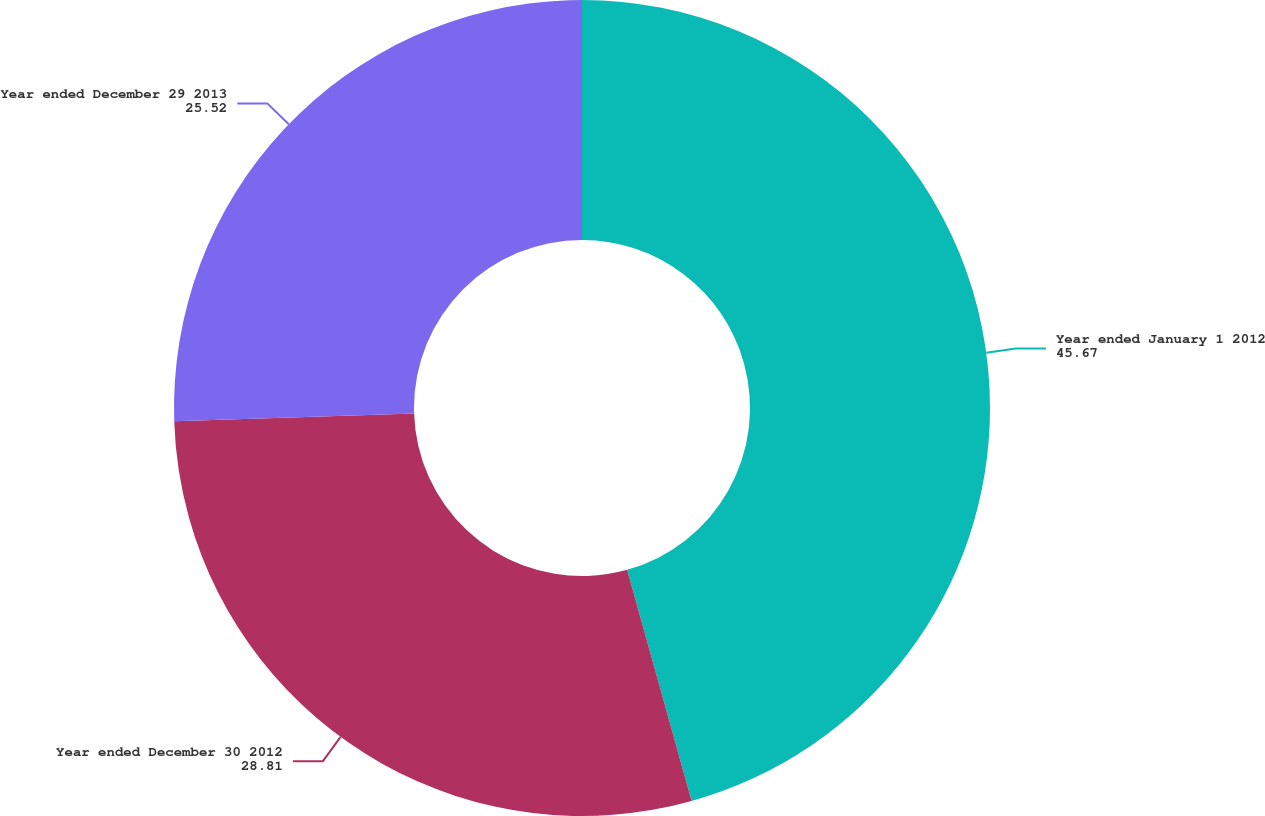<chart> <loc_0><loc_0><loc_500><loc_500><pie_chart><fcel>Year ended January 1 2012<fcel>Year ended December 30 2012<fcel>Year ended December 29 2013<nl><fcel>45.67%<fcel>28.81%<fcel>25.52%<nl></chart> 